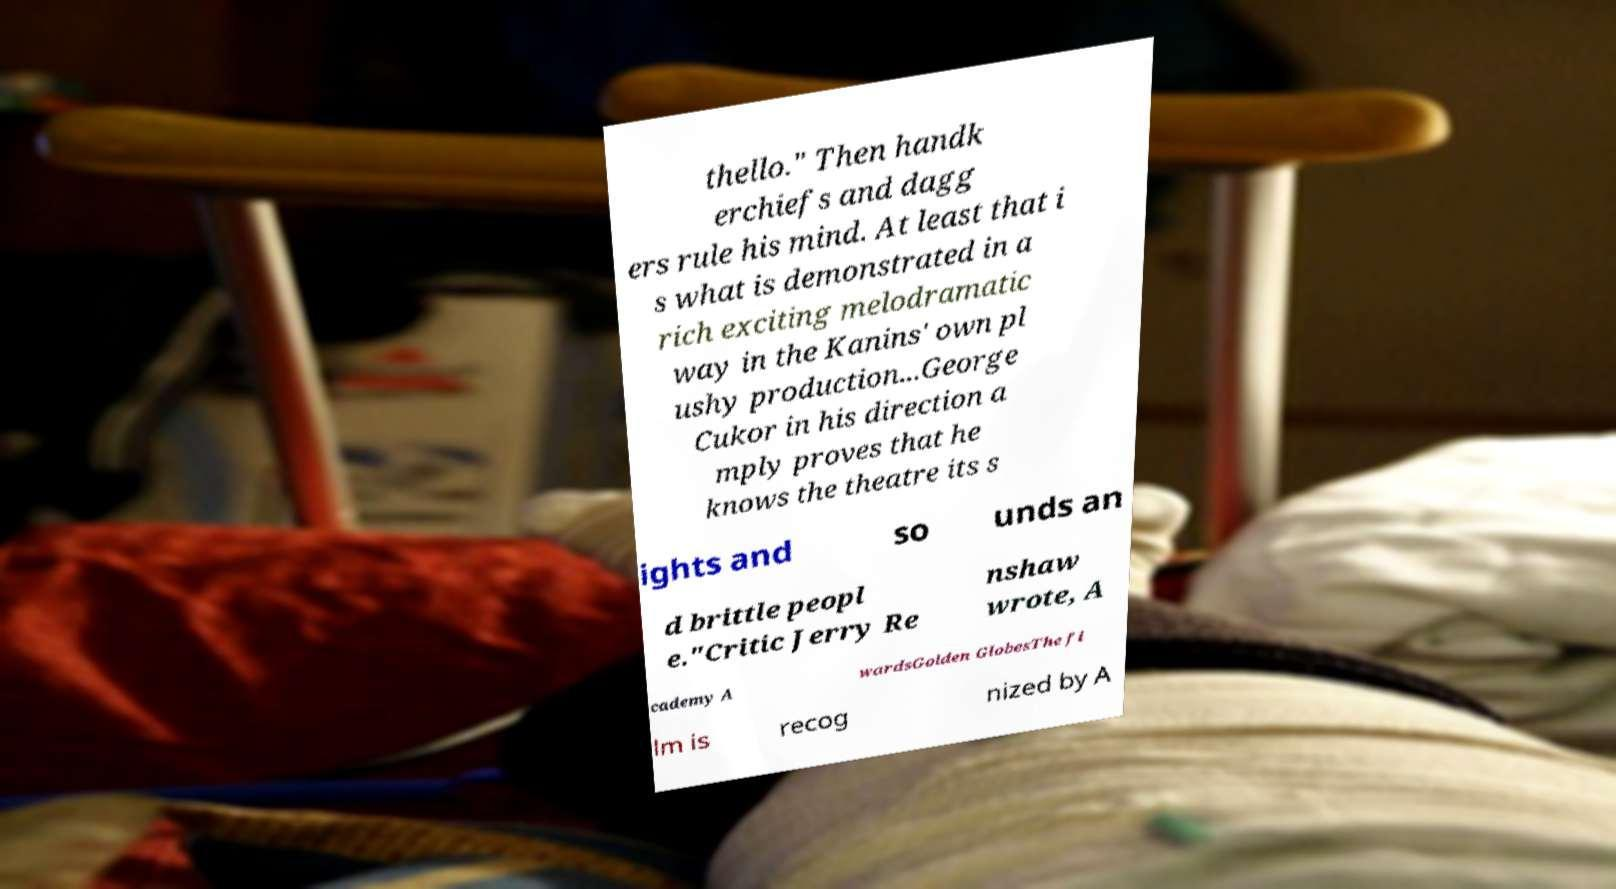I need the written content from this picture converted into text. Can you do that? thello." Then handk erchiefs and dagg ers rule his mind. At least that i s what is demonstrated in a rich exciting melodramatic way in the Kanins' own pl ushy production...George Cukor in his direction a mply proves that he knows the theatre its s ights and so unds an d brittle peopl e."Critic Jerry Re nshaw wrote, A cademy A wardsGolden GlobesThe fi lm is recog nized by A 